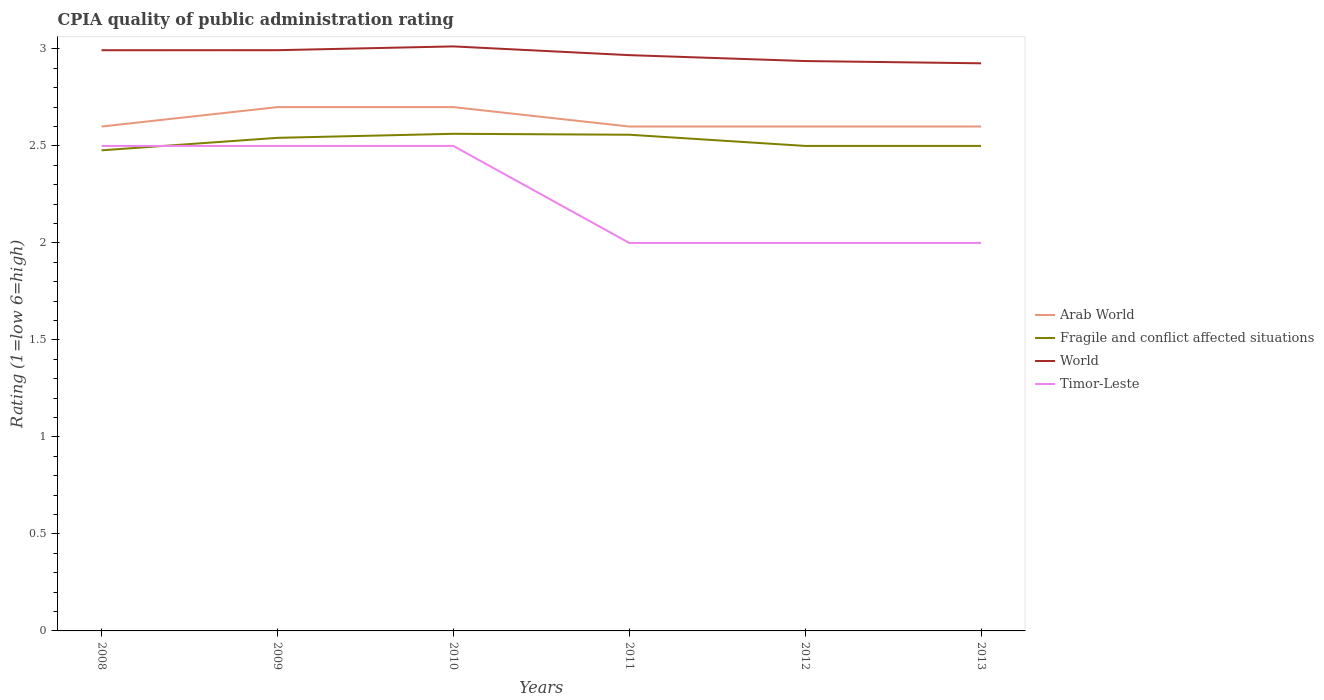How many different coloured lines are there?
Provide a short and direct response. 4. Does the line corresponding to Fragile and conflict affected situations intersect with the line corresponding to Timor-Leste?
Provide a succinct answer. Yes. Across all years, what is the maximum CPIA rating in World?
Give a very brief answer. 2.93. What is the total CPIA rating in Fragile and conflict affected situations in the graph?
Keep it short and to the point. -0.02. What is the difference between the highest and the second highest CPIA rating in World?
Make the answer very short. 0.09. How many lines are there?
Your answer should be very brief. 4. What is the difference between two consecutive major ticks on the Y-axis?
Ensure brevity in your answer.  0.5. Are the values on the major ticks of Y-axis written in scientific E-notation?
Offer a very short reply. No. Does the graph contain any zero values?
Your answer should be compact. No. How many legend labels are there?
Offer a terse response. 4. How are the legend labels stacked?
Keep it short and to the point. Vertical. What is the title of the graph?
Your answer should be compact. CPIA quality of public administration rating. Does "Montenegro" appear as one of the legend labels in the graph?
Your answer should be very brief. No. What is the label or title of the X-axis?
Your answer should be compact. Years. What is the label or title of the Y-axis?
Offer a terse response. Rating (1=low 6=high). What is the Rating (1=low 6=high) of Fragile and conflict affected situations in 2008?
Ensure brevity in your answer.  2.48. What is the Rating (1=low 6=high) of World in 2008?
Offer a very short reply. 2.99. What is the Rating (1=low 6=high) of Timor-Leste in 2008?
Offer a very short reply. 2.5. What is the Rating (1=low 6=high) in Arab World in 2009?
Offer a very short reply. 2.7. What is the Rating (1=low 6=high) in Fragile and conflict affected situations in 2009?
Your answer should be very brief. 2.54. What is the Rating (1=low 6=high) in World in 2009?
Your answer should be very brief. 2.99. What is the Rating (1=low 6=high) of Arab World in 2010?
Give a very brief answer. 2.7. What is the Rating (1=low 6=high) of Fragile and conflict affected situations in 2010?
Your answer should be compact. 2.56. What is the Rating (1=low 6=high) of World in 2010?
Provide a succinct answer. 3.01. What is the Rating (1=low 6=high) in Timor-Leste in 2010?
Ensure brevity in your answer.  2.5. What is the Rating (1=low 6=high) in Arab World in 2011?
Keep it short and to the point. 2.6. What is the Rating (1=low 6=high) in Fragile and conflict affected situations in 2011?
Your response must be concise. 2.56. What is the Rating (1=low 6=high) in World in 2011?
Make the answer very short. 2.97. What is the Rating (1=low 6=high) in Timor-Leste in 2011?
Your response must be concise. 2. What is the Rating (1=low 6=high) in Fragile and conflict affected situations in 2012?
Ensure brevity in your answer.  2.5. What is the Rating (1=low 6=high) of World in 2012?
Provide a short and direct response. 2.94. What is the Rating (1=low 6=high) in Fragile and conflict affected situations in 2013?
Offer a very short reply. 2.5. What is the Rating (1=low 6=high) in World in 2013?
Provide a succinct answer. 2.93. What is the Rating (1=low 6=high) of Timor-Leste in 2013?
Offer a very short reply. 2. Across all years, what is the maximum Rating (1=low 6=high) in Arab World?
Make the answer very short. 2.7. Across all years, what is the maximum Rating (1=low 6=high) in Fragile and conflict affected situations?
Make the answer very short. 2.56. Across all years, what is the maximum Rating (1=low 6=high) in World?
Your response must be concise. 3.01. Across all years, what is the maximum Rating (1=low 6=high) in Timor-Leste?
Offer a very short reply. 2.5. Across all years, what is the minimum Rating (1=low 6=high) of Fragile and conflict affected situations?
Offer a very short reply. 2.48. Across all years, what is the minimum Rating (1=low 6=high) in World?
Make the answer very short. 2.93. What is the total Rating (1=low 6=high) of Arab World in the graph?
Offer a very short reply. 15.8. What is the total Rating (1=low 6=high) in Fragile and conflict affected situations in the graph?
Your answer should be compact. 15.14. What is the total Rating (1=low 6=high) in World in the graph?
Give a very brief answer. 17.83. What is the difference between the Rating (1=low 6=high) of Arab World in 2008 and that in 2009?
Keep it short and to the point. -0.1. What is the difference between the Rating (1=low 6=high) in Fragile and conflict affected situations in 2008 and that in 2009?
Your answer should be very brief. -0.06. What is the difference between the Rating (1=low 6=high) in World in 2008 and that in 2009?
Give a very brief answer. -0. What is the difference between the Rating (1=low 6=high) in Fragile and conflict affected situations in 2008 and that in 2010?
Offer a terse response. -0.09. What is the difference between the Rating (1=low 6=high) in World in 2008 and that in 2010?
Provide a short and direct response. -0.02. What is the difference between the Rating (1=low 6=high) in Timor-Leste in 2008 and that in 2010?
Your answer should be compact. 0. What is the difference between the Rating (1=low 6=high) in Arab World in 2008 and that in 2011?
Provide a succinct answer. 0. What is the difference between the Rating (1=low 6=high) in Fragile and conflict affected situations in 2008 and that in 2011?
Offer a very short reply. -0.08. What is the difference between the Rating (1=low 6=high) of World in 2008 and that in 2011?
Offer a terse response. 0.03. What is the difference between the Rating (1=low 6=high) in Timor-Leste in 2008 and that in 2011?
Your answer should be very brief. 0.5. What is the difference between the Rating (1=low 6=high) in Arab World in 2008 and that in 2012?
Give a very brief answer. 0. What is the difference between the Rating (1=low 6=high) in Fragile and conflict affected situations in 2008 and that in 2012?
Give a very brief answer. -0.02. What is the difference between the Rating (1=low 6=high) in World in 2008 and that in 2012?
Your response must be concise. 0.06. What is the difference between the Rating (1=low 6=high) of Arab World in 2008 and that in 2013?
Your answer should be very brief. 0. What is the difference between the Rating (1=low 6=high) in Fragile and conflict affected situations in 2008 and that in 2013?
Give a very brief answer. -0.02. What is the difference between the Rating (1=low 6=high) in World in 2008 and that in 2013?
Your response must be concise. 0.07. What is the difference between the Rating (1=low 6=high) of Timor-Leste in 2008 and that in 2013?
Make the answer very short. 0.5. What is the difference between the Rating (1=low 6=high) in Fragile and conflict affected situations in 2009 and that in 2010?
Your response must be concise. -0.02. What is the difference between the Rating (1=low 6=high) of World in 2009 and that in 2010?
Make the answer very short. -0.02. What is the difference between the Rating (1=low 6=high) of Fragile and conflict affected situations in 2009 and that in 2011?
Give a very brief answer. -0.02. What is the difference between the Rating (1=low 6=high) of World in 2009 and that in 2011?
Offer a very short reply. 0.03. What is the difference between the Rating (1=low 6=high) in Arab World in 2009 and that in 2012?
Keep it short and to the point. 0.1. What is the difference between the Rating (1=low 6=high) of Fragile and conflict affected situations in 2009 and that in 2012?
Provide a succinct answer. 0.04. What is the difference between the Rating (1=low 6=high) in World in 2009 and that in 2012?
Make the answer very short. 0.06. What is the difference between the Rating (1=low 6=high) in Timor-Leste in 2009 and that in 2012?
Keep it short and to the point. 0.5. What is the difference between the Rating (1=low 6=high) in Fragile and conflict affected situations in 2009 and that in 2013?
Offer a terse response. 0.04. What is the difference between the Rating (1=low 6=high) in World in 2009 and that in 2013?
Your answer should be very brief. 0.07. What is the difference between the Rating (1=low 6=high) in Fragile and conflict affected situations in 2010 and that in 2011?
Make the answer very short. 0. What is the difference between the Rating (1=low 6=high) in World in 2010 and that in 2011?
Make the answer very short. 0.04. What is the difference between the Rating (1=low 6=high) in Timor-Leste in 2010 and that in 2011?
Your response must be concise. 0.5. What is the difference between the Rating (1=low 6=high) in Arab World in 2010 and that in 2012?
Your response must be concise. 0.1. What is the difference between the Rating (1=low 6=high) in Fragile and conflict affected situations in 2010 and that in 2012?
Keep it short and to the point. 0.06. What is the difference between the Rating (1=low 6=high) in World in 2010 and that in 2012?
Offer a terse response. 0.08. What is the difference between the Rating (1=low 6=high) in Timor-Leste in 2010 and that in 2012?
Ensure brevity in your answer.  0.5. What is the difference between the Rating (1=low 6=high) of Arab World in 2010 and that in 2013?
Ensure brevity in your answer.  0.1. What is the difference between the Rating (1=low 6=high) of Fragile and conflict affected situations in 2010 and that in 2013?
Ensure brevity in your answer.  0.06. What is the difference between the Rating (1=low 6=high) in World in 2010 and that in 2013?
Ensure brevity in your answer.  0.09. What is the difference between the Rating (1=low 6=high) in Fragile and conflict affected situations in 2011 and that in 2012?
Make the answer very short. 0.06. What is the difference between the Rating (1=low 6=high) in World in 2011 and that in 2012?
Provide a succinct answer. 0.03. What is the difference between the Rating (1=low 6=high) of Fragile and conflict affected situations in 2011 and that in 2013?
Provide a succinct answer. 0.06. What is the difference between the Rating (1=low 6=high) of World in 2011 and that in 2013?
Provide a succinct answer. 0.04. What is the difference between the Rating (1=low 6=high) in Timor-Leste in 2011 and that in 2013?
Your response must be concise. 0. What is the difference between the Rating (1=low 6=high) in Fragile and conflict affected situations in 2012 and that in 2013?
Your response must be concise. 0. What is the difference between the Rating (1=low 6=high) of World in 2012 and that in 2013?
Offer a terse response. 0.01. What is the difference between the Rating (1=low 6=high) in Timor-Leste in 2012 and that in 2013?
Your answer should be compact. 0. What is the difference between the Rating (1=low 6=high) in Arab World in 2008 and the Rating (1=low 6=high) in Fragile and conflict affected situations in 2009?
Give a very brief answer. 0.06. What is the difference between the Rating (1=low 6=high) of Arab World in 2008 and the Rating (1=low 6=high) of World in 2009?
Provide a succinct answer. -0.39. What is the difference between the Rating (1=low 6=high) of Fragile and conflict affected situations in 2008 and the Rating (1=low 6=high) of World in 2009?
Your response must be concise. -0.52. What is the difference between the Rating (1=low 6=high) in Fragile and conflict affected situations in 2008 and the Rating (1=low 6=high) in Timor-Leste in 2009?
Give a very brief answer. -0.02. What is the difference between the Rating (1=low 6=high) in World in 2008 and the Rating (1=low 6=high) in Timor-Leste in 2009?
Ensure brevity in your answer.  0.49. What is the difference between the Rating (1=low 6=high) in Arab World in 2008 and the Rating (1=low 6=high) in Fragile and conflict affected situations in 2010?
Provide a short and direct response. 0.04. What is the difference between the Rating (1=low 6=high) in Arab World in 2008 and the Rating (1=low 6=high) in World in 2010?
Offer a very short reply. -0.41. What is the difference between the Rating (1=low 6=high) in Fragile and conflict affected situations in 2008 and the Rating (1=low 6=high) in World in 2010?
Make the answer very short. -0.54. What is the difference between the Rating (1=low 6=high) of Fragile and conflict affected situations in 2008 and the Rating (1=low 6=high) of Timor-Leste in 2010?
Ensure brevity in your answer.  -0.02. What is the difference between the Rating (1=low 6=high) in World in 2008 and the Rating (1=low 6=high) in Timor-Leste in 2010?
Provide a succinct answer. 0.49. What is the difference between the Rating (1=low 6=high) of Arab World in 2008 and the Rating (1=low 6=high) of Fragile and conflict affected situations in 2011?
Offer a very short reply. 0.04. What is the difference between the Rating (1=low 6=high) in Arab World in 2008 and the Rating (1=low 6=high) in World in 2011?
Your answer should be very brief. -0.37. What is the difference between the Rating (1=low 6=high) of Fragile and conflict affected situations in 2008 and the Rating (1=low 6=high) of World in 2011?
Ensure brevity in your answer.  -0.49. What is the difference between the Rating (1=low 6=high) of Fragile and conflict affected situations in 2008 and the Rating (1=low 6=high) of Timor-Leste in 2011?
Give a very brief answer. 0.48. What is the difference between the Rating (1=low 6=high) in World in 2008 and the Rating (1=low 6=high) in Timor-Leste in 2011?
Provide a succinct answer. 0.99. What is the difference between the Rating (1=low 6=high) of Arab World in 2008 and the Rating (1=low 6=high) of World in 2012?
Your answer should be compact. -0.34. What is the difference between the Rating (1=low 6=high) in Arab World in 2008 and the Rating (1=low 6=high) in Timor-Leste in 2012?
Your answer should be compact. 0.6. What is the difference between the Rating (1=low 6=high) of Fragile and conflict affected situations in 2008 and the Rating (1=low 6=high) of World in 2012?
Provide a succinct answer. -0.46. What is the difference between the Rating (1=low 6=high) of Fragile and conflict affected situations in 2008 and the Rating (1=low 6=high) of Timor-Leste in 2012?
Offer a terse response. 0.48. What is the difference between the Rating (1=low 6=high) in Arab World in 2008 and the Rating (1=low 6=high) in Fragile and conflict affected situations in 2013?
Your answer should be compact. 0.1. What is the difference between the Rating (1=low 6=high) of Arab World in 2008 and the Rating (1=low 6=high) of World in 2013?
Your answer should be very brief. -0.33. What is the difference between the Rating (1=low 6=high) of Fragile and conflict affected situations in 2008 and the Rating (1=low 6=high) of World in 2013?
Make the answer very short. -0.45. What is the difference between the Rating (1=low 6=high) of Fragile and conflict affected situations in 2008 and the Rating (1=low 6=high) of Timor-Leste in 2013?
Provide a short and direct response. 0.48. What is the difference between the Rating (1=low 6=high) in World in 2008 and the Rating (1=low 6=high) in Timor-Leste in 2013?
Make the answer very short. 0.99. What is the difference between the Rating (1=low 6=high) in Arab World in 2009 and the Rating (1=low 6=high) in Fragile and conflict affected situations in 2010?
Offer a very short reply. 0.14. What is the difference between the Rating (1=low 6=high) of Arab World in 2009 and the Rating (1=low 6=high) of World in 2010?
Provide a succinct answer. -0.31. What is the difference between the Rating (1=low 6=high) of Arab World in 2009 and the Rating (1=low 6=high) of Timor-Leste in 2010?
Give a very brief answer. 0.2. What is the difference between the Rating (1=low 6=high) in Fragile and conflict affected situations in 2009 and the Rating (1=low 6=high) in World in 2010?
Your answer should be compact. -0.47. What is the difference between the Rating (1=low 6=high) of Fragile and conflict affected situations in 2009 and the Rating (1=low 6=high) of Timor-Leste in 2010?
Provide a succinct answer. 0.04. What is the difference between the Rating (1=low 6=high) of World in 2009 and the Rating (1=low 6=high) of Timor-Leste in 2010?
Offer a very short reply. 0.49. What is the difference between the Rating (1=low 6=high) in Arab World in 2009 and the Rating (1=low 6=high) in Fragile and conflict affected situations in 2011?
Your answer should be very brief. 0.14. What is the difference between the Rating (1=low 6=high) of Arab World in 2009 and the Rating (1=low 6=high) of World in 2011?
Provide a short and direct response. -0.27. What is the difference between the Rating (1=low 6=high) of Fragile and conflict affected situations in 2009 and the Rating (1=low 6=high) of World in 2011?
Offer a terse response. -0.43. What is the difference between the Rating (1=low 6=high) in Fragile and conflict affected situations in 2009 and the Rating (1=low 6=high) in Timor-Leste in 2011?
Ensure brevity in your answer.  0.54. What is the difference between the Rating (1=low 6=high) of World in 2009 and the Rating (1=low 6=high) of Timor-Leste in 2011?
Make the answer very short. 0.99. What is the difference between the Rating (1=low 6=high) in Arab World in 2009 and the Rating (1=low 6=high) in Fragile and conflict affected situations in 2012?
Offer a terse response. 0.2. What is the difference between the Rating (1=low 6=high) of Arab World in 2009 and the Rating (1=low 6=high) of World in 2012?
Provide a short and direct response. -0.24. What is the difference between the Rating (1=low 6=high) of Arab World in 2009 and the Rating (1=low 6=high) of Timor-Leste in 2012?
Offer a terse response. 0.7. What is the difference between the Rating (1=low 6=high) in Fragile and conflict affected situations in 2009 and the Rating (1=low 6=high) in World in 2012?
Provide a short and direct response. -0.4. What is the difference between the Rating (1=low 6=high) in Fragile and conflict affected situations in 2009 and the Rating (1=low 6=high) in Timor-Leste in 2012?
Your answer should be very brief. 0.54. What is the difference between the Rating (1=low 6=high) in Arab World in 2009 and the Rating (1=low 6=high) in Fragile and conflict affected situations in 2013?
Your answer should be compact. 0.2. What is the difference between the Rating (1=low 6=high) in Arab World in 2009 and the Rating (1=low 6=high) in World in 2013?
Ensure brevity in your answer.  -0.23. What is the difference between the Rating (1=low 6=high) in Arab World in 2009 and the Rating (1=low 6=high) in Timor-Leste in 2013?
Provide a succinct answer. 0.7. What is the difference between the Rating (1=low 6=high) in Fragile and conflict affected situations in 2009 and the Rating (1=low 6=high) in World in 2013?
Offer a very short reply. -0.38. What is the difference between the Rating (1=low 6=high) in Fragile and conflict affected situations in 2009 and the Rating (1=low 6=high) in Timor-Leste in 2013?
Offer a terse response. 0.54. What is the difference between the Rating (1=low 6=high) of Arab World in 2010 and the Rating (1=low 6=high) of Fragile and conflict affected situations in 2011?
Your answer should be very brief. 0.14. What is the difference between the Rating (1=low 6=high) of Arab World in 2010 and the Rating (1=low 6=high) of World in 2011?
Your response must be concise. -0.27. What is the difference between the Rating (1=low 6=high) in Fragile and conflict affected situations in 2010 and the Rating (1=low 6=high) in World in 2011?
Your response must be concise. -0.41. What is the difference between the Rating (1=low 6=high) in Fragile and conflict affected situations in 2010 and the Rating (1=low 6=high) in Timor-Leste in 2011?
Offer a very short reply. 0.56. What is the difference between the Rating (1=low 6=high) in World in 2010 and the Rating (1=low 6=high) in Timor-Leste in 2011?
Offer a terse response. 1.01. What is the difference between the Rating (1=low 6=high) in Arab World in 2010 and the Rating (1=low 6=high) in Fragile and conflict affected situations in 2012?
Give a very brief answer. 0.2. What is the difference between the Rating (1=low 6=high) in Arab World in 2010 and the Rating (1=low 6=high) in World in 2012?
Offer a terse response. -0.24. What is the difference between the Rating (1=low 6=high) in Arab World in 2010 and the Rating (1=low 6=high) in Timor-Leste in 2012?
Your response must be concise. 0.7. What is the difference between the Rating (1=low 6=high) of Fragile and conflict affected situations in 2010 and the Rating (1=low 6=high) of World in 2012?
Offer a very short reply. -0.38. What is the difference between the Rating (1=low 6=high) of Fragile and conflict affected situations in 2010 and the Rating (1=low 6=high) of Timor-Leste in 2012?
Provide a short and direct response. 0.56. What is the difference between the Rating (1=low 6=high) in Arab World in 2010 and the Rating (1=low 6=high) in Fragile and conflict affected situations in 2013?
Make the answer very short. 0.2. What is the difference between the Rating (1=low 6=high) of Arab World in 2010 and the Rating (1=low 6=high) of World in 2013?
Your answer should be very brief. -0.23. What is the difference between the Rating (1=low 6=high) of Fragile and conflict affected situations in 2010 and the Rating (1=low 6=high) of World in 2013?
Offer a very short reply. -0.36. What is the difference between the Rating (1=low 6=high) of Fragile and conflict affected situations in 2010 and the Rating (1=low 6=high) of Timor-Leste in 2013?
Provide a short and direct response. 0.56. What is the difference between the Rating (1=low 6=high) in Arab World in 2011 and the Rating (1=low 6=high) in World in 2012?
Provide a short and direct response. -0.34. What is the difference between the Rating (1=low 6=high) in Fragile and conflict affected situations in 2011 and the Rating (1=low 6=high) in World in 2012?
Keep it short and to the point. -0.38. What is the difference between the Rating (1=low 6=high) in Fragile and conflict affected situations in 2011 and the Rating (1=low 6=high) in Timor-Leste in 2012?
Make the answer very short. 0.56. What is the difference between the Rating (1=low 6=high) of World in 2011 and the Rating (1=low 6=high) of Timor-Leste in 2012?
Your response must be concise. 0.97. What is the difference between the Rating (1=low 6=high) in Arab World in 2011 and the Rating (1=low 6=high) in Fragile and conflict affected situations in 2013?
Offer a very short reply. 0.1. What is the difference between the Rating (1=low 6=high) of Arab World in 2011 and the Rating (1=low 6=high) of World in 2013?
Offer a very short reply. -0.33. What is the difference between the Rating (1=low 6=high) in Fragile and conflict affected situations in 2011 and the Rating (1=low 6=high) in World in 2013?
Your answer should be very brief. -0.37. What is the difference between the Rating (1=low 6=high) in Fragile and conflict affected situations in 2011 and the Rating (1=low 6=high) in Timor-Leste in 2013?
Make the answer very short. 0.56. What is the difference between the Rating (1=low 6=high) of World in 2011 and the Rating (1=low 6=high) of Timor-Leste in 2013?
Keep it short and to the point. 0.97. What is the difference between the Rating (1=low 6=high) in Arab World in 2012 and the Rating (1=low 6=high) in World in 2013?
Your answer should be very brief. -0.33. What is the difference between the Rating (1=low 6=high) in Arab World in 2012 and the Rating (1=low 6=high) in Timor-Leste in 2013?
Your answer should be very brief. 0.6. What is the difference between the Rating (1=low 6=high) of Fragile and conflict affected situations in 2012 and the Rating (1=low 6=high) of World in 2013?
Offer a very short reply. -0.43. What is the difference between the Rating (1=low 6=high) in Fragile and conflict affected situations in 2012 and the Rating (1=low 6=high) in Timor-Leste in 2013?
Your answer should be very brief. 0.5. What is the difference between the Rating (1=low 6=high) of World in 2012 and the Rating (1=low 6=high) of Timor-Leste in 2013?
Your answer should be very brief. 0.94. What is the average Rating (1=low 6=high) in Arab World per year?
Offer a very short reply. 2.63. What is the average Rating (1=low 6=high) in Fragile and conflict affected situations per year?
Ensure brevity in your answer.  2.52. What is the average Rating (1=low 6=high) in World per year?
Ensure brevity in your answer.  2.97. What is the average Rating (1=low 6=high) in Timor-Leste per year?
Provide a succinct answer. 2.25. In the year 2008, what is the difference between the Rating (1=low 6=high) in Arab World and Rating (1=low 6=high) in Fragile and conflict affected situations?
Your response must be concise. 0.12. In the year 2008, what is the difference between the Rating (1=low 6=high) in Arab World and Rating (1=low 6=high) in World?
Offer a terse response. -0.39. In the year 2008, what is the difference between the Rating (1=low 6=high) in Fragile and conflict affected situations and Rating (1=low 6=high) in World?
Make the answer very short. -0.52. In the year 2008, what is the difference between the Rating (1=low 6=high) in Fragile and conflict affected situations and Rating (1=low 6=high) in Timor-Leste?
Make the answer very short. -0.02. In the year 2008, what is the difference between the Rating (1=low 6=high) in World and Rating (1=low 6=high) in Timor-Leste?
Keep it short and to the point. 0.49. In the year 2009, what is the difference between the Rating (1=low 6=high) of Arab World and Rating (1=low 6=high) of Fragile and conflict affected situations?
Offer a terse response. 0.16. In the year 2009, what is the difference between the Rating (1=low 6=high) of Arab World and Rating (1=low 6=high) of World?
Make the answer very short. -0.29. In the year 2009, what is the difference between the Rating (1=low 6=high) in Fragile and conflict affected situations and Rating (1=low 6=high) in World?
Provide a short and direct response. -0.45. In the year 2009, what is the difference between the Rating (1=low 6=high) in Fragile and conflict affected situations and Rating (1=low 6=high) in Timor-Leste?
Offer a very short reply. 0.04. In the year 2009, what is the difference between the Rating (1=low 6=high) in World and Rating (1=low 6=high) in Timor-Leste?
Provide a succinct answer. 0.49. In the year 2010, what is the difference between the Rating (1=low 6=high) in Arab World and Rating (1=low 6=high) in Fragile and conflict affected situations?
Make the answer very short. 0.14. In the year 2010, what is the difference between the Rating (1=low 6=high) of Arab World and Rating (1=low 6=high) of World?
Ensure brevity in your answer.  -0.31. In the year 2010, what is the difference between the Rating (1=low 6=high) in Arab World and Rating (1=low 6=high) in Timor-Leste?
Provide a short and direct response. 0.2. In the year 2010, what is the difference between the Rating (1=low 6=high) of Fragile and conflict affected situations and Rating (1=low 6=high) of World?
Offer a terse response. -0.45. In the year 2010, what is the difference between the Rating (1=low 6=high) in Fragile and conflict affected situations and Rating (1=low 6=high) in Timor-Leste?
Ensure brevity in your answer.  0.06. In the year 2010, what is the difference between the Rating (1=low 6=high) in World and Rating (1=low 6=high) in Timor-Leste?
Ensure brevity in your answer.  0.51. In the year 2011, what is the difference between the Rating (1=low 6=high) of Arab World and Rating (1=low 6=high) of Fragile and conflict affected situations?
Provide a succinct answer. 0.04. In the year 2011, what is the difference between the Rating (1=low 6=high) in Arab World and Rating (1=low 6=high) in World?
Offer a terse response. -0.37. In the year 2011, what is the difference between the Rating (1=low 6=high) in Fragile and conflict affected situations and Rating (1=low 6=high) in World?
Your response must be concise. -0.41. In the year 2011, what is the difference between the Rating (1=low 6=high) in Fragile and conflict affected situations and Rating (1=low 6=high) in Timor-Leste?
Give a very brief answer. 0.56. In the year 2011, what is the difference between the Rating (1=low 6=high) of World and Rating (1=low 6=high) of Timor-Leste?
Your answer should be compact. 0.97. In the year 2012, what is the difference between the Rating (1=low 6=high) in Arab World and Rating (1=low 6=high) in World?
Give a very brief answer. -0.34. In the year 2012, what is the difference between the Rating (1=low 6=high) of Fragile and conflict affected situations and Rating (1=low 6=high) of World?
Provide a succinct answer. -0.44. In the year 2012, what is the difference between the Rating (1=low 6=high) of World and Rating (1=low 6=high) of Timor-Leste?
Give a very brief answer. 0.94. In the year 2013, what is the difference between the Rating (1=low 6=high) in Arab World and Rating (1=low 6=high) in Fragile and conflict affected situations?
Your response must be concise. 0.1. In the year 2013, what is the difference between the Rating (1=low 6=high) of Arab World and Rating (1=low 6=high) of World?
Ensure brevity in your answer.  -0.33. In the year 2013, what is the difference between the Rating (1=low 6=high) of Fragile and conflict affected situations and Rating (1=low 6=high) of World?
Provide a succinct answer. -0.43. In the year 2013, what is the difference between the Rating (1=low 6=high) in Fragile and conflict affected situations and Rating (1=low 6=high) in Timor-Leste?
Give a very brief answer. 0.5. In the year 2013, what is the difference between the Rating (1=low 6=high) in World and Rating (1=low 6=high) in Timor-Leste?
Your answer should be compact. 0.93. What is the ratio of the Rating (1=low 6=high) in Fragile and conflict affected situations in 2008 to that in 2009?
Keep it short and to the point. 0.97. What is the ratio of the Rating (1=low 6=high) in World in 2008 to that in 2009?
Keep it short and to the point. 1. What is the ratio of the Rating (1=low 6=high) in Fragile and conflict affected situations in 2008 to that in 2010?
Ensure brevity in your answer.  0.97. What is the ratio of the Rating (1=low 6=high) in Arab World in 2008 to that in 2011?
Offer a terse response. 1. What is the ratio of the Rating (1=low 6=high) in Fragile and conflict affected situations in 2008 to that in 2011?
Offer a very short reply. 0.97. What is the ratio of the Rating (1=low 6=high) in World in 2008 to that in 2011?
Your answer should be compact. 1.01. What is the ratio of the Rating (1=low 6=high) of Timor-Leste in 2008 to that in 2011?
Your response must be concise. 1.25. What is the ratio of the Rating (1=low 6=high) in Fragile and conflict affected situations in 2008 to that in 2012?
Make the answer very short. 0.99. What is the ratio of the Rating (1=low 6=high) of World in 2008 to that in 2012?
Give a very brief answer. 1.02. What is the ratio of the Rating (1=low 6=high) in Timor-Leste in 2008 to that in 2012?
Your answer should be compact. 1.25. What is the ratio of the Rating (1=low 6=high) of Arab World in 2008 to that in 2013?
Keep it short and to the point. 1. What is the ratio of the Rating (1=low 6=high) of Fragile and conflict affected situations in 2008 to that in 2013?
Your answer should be compact. 0.99. What is the ratio of the Rating (1=low 6=high) of Timor-Leste in 2009 to that in 2010?
Make the answer very short. 1. What is the ratio of the Rating (1=low 6=high) of Fragile and conflict affected situations in 2009 to that in 2011?
Make the answer very short. 0.99. What is the ratio of the Rating (1=low 6=high) of World in 2009 to that in 2011?
Offer a terse response. 1.01. What is the ratio of the Rating (1=low 6=high) in Arab World in 2009 to that in 2012?
Make the answer very short. 1.04. What is the ratio of the Rating (1=low 6=high) of Fragile and conflict affected situations in 2009 to that in 2012?
Your answer should be compact. 1.02. What is the ratio of the Rating (1=low 6=high) in World in 2009 to that in 2012?
Offer a terse response. 1.02. What is the ratio of the Rating (1=low 6=high) of Arab World in 2009 to that in 2013?
Provide a short and direct response. 1.04. What is the ratio of the Rating (1=low 6=high) in Fragile and conflict affected situations in 2009 to that in 2013?
Your answer should be very brief. 1.02. What is the ratio of the Rating (1=low 6=high) of World in 2009 to that in 2013?
Provide a succinct answer. 1.02. What is the ratio of the Rating (1=low 6=high) in Arab World in 2010 to that in 2011?
Offer a terse response. 1.04. What is the ratio of the Rating (1=low 6=high) in Fragile and conflict affected situations in 2010 to that in 2011?
Make the answer very short. 1. What is the ratio of the Rating (1=low 6=high) in World in 2010 to that in 2011?
Your answer should be very brief. 1.02. What is the ratio of the Rating (1=low 6=high) of Arab World in 2010 to that in 2012?
Provide a succinct answer. 1.04. What is the ratio of the Rating (1=low 6=high) in Fragile and conflict affected situations in 2010 to that in 2012?
Offer a terse response. 1.02. What is the ratio of the Rating (1=low 6=high) in World in 2010 to that in 2012?
Give a very brief answer. 1.03. What is the ratio of the Rating (1=low 6=high) of Timor-Leste in 2010 to that in 2012?
Offer a terse response. 1.25. What is the ratio of the Rating (1=low 6=high) of Arab World in 2010 to that in 2013?
Your answer should be very brief. 1.04. What is the ratio of the Rating (1=low 6=high) of Fragile and conflict affected situations in 2010 to that in 2013?
Keep it short and to the point. 1.02. What is the ratio of the Rating (1=low 6=high) in World in 2010 to that in 2013?
Give a very brief answer. 1.03. What is the ratio of the Rating (1=low 6=high) of Arab World in 2011 to that in 2012?
Your answer should be very brief. 1. What is the ratio of the Rating (1=low 6=high) in Fragile and conflict affected situations in 2011 to that in 2012?
Your answer should be very brief. 1.02. What is the ratio of the Rating (1=low 6=high) of World in 2011 to that in 2012?
Offer a very short reply. 1.01. What is the ratio of the Rating (1=low 6=high) of Timor-Leste in 2011 to that in 2012?
Ensure brevity in your answer.  1. What is the ratio of the Rating (1=low 6=high) in Fragile and conflict affected situations in 2011 to that in 2013?
Offer a terse response. 1.02. What is the ratio of the Rating (1=low 6=high) of World in 2011 to that in 2013?
Your response must be concise. 1.01. What is the ratio of the Rating (1=low 6=high) of Fragile and conflict affected situations in 2012 to that in 2013?
Offer a terse response. 1. What is the ratio of the Rating (1=low 6=high) in World in 2012 to that in 2013?
Ensure brevity in your answer.  1. What is the ratio of the Rating (1=low 6=high) of Timor-Leste in 2012 to that in 2013?
Keep it short and to the point. 1. What is the difference between the highest and the second highest Rating (1=low 6=high) in Arab World?
Offer a very short reply. 0. What is the difference between the highest and the second highest Rating (1=low 6=high) of Fragile and conflict affected situations?
Ensure brevity in your answer.  0. What is the difference between the highest and the second highest Rating (1=low 6=high) of World?
Keep it short and to the point. 0.02. What is the difference between the highest and the lowest Rating (1=low 6=high) in Arab World?
Ensure brevity in your answer.  0.1. What is the difference between the highest and the lowest Rating (1=low 6=high) of Fragile and conflict affected situations?
Make the answer very short. 0.09. What is the difference between the highest and the lowest Rating (1=low 6=high) in World?
Keep it short and to the point. 0.09. What is the difference between the highest and the lowest Rating (1=low 6=high) in Timor-Leste?
Your response must be concise. 0.5. 